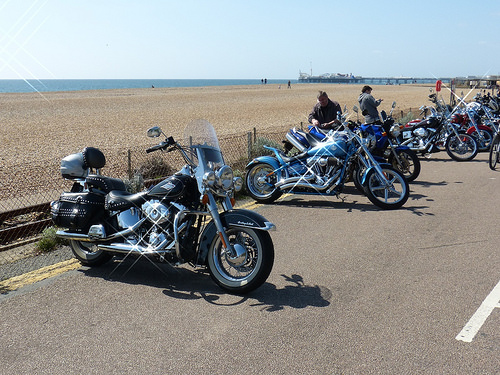<image>
Is there a man on the bike? No. The man is not positioned on the bike. They may be near each other, but the man is not supported by or resting on top of the bike. Where is the bike in relation to the man? Is it behind the man? No. The bike is not behind the man. From this viewpoint, the bike appears to be positioned elsewhere in the scene. Is the man in the water? No. The man is not contained within the water. These objects have a different spatial relationship. 